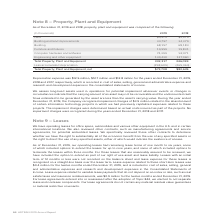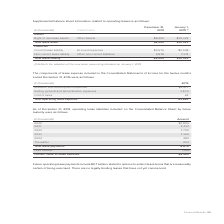According to Adtran's financial document, What types of operating leases does the company have in the U.S. and in certain international locations? office space, automobiles and various other equipment. The document states: "We have operating leases for office space, automobiles and various other equipment in the U.S. and in certain international locations. We also reviewe..." Also, What was the right of use lease assets in December 2019? According to the financial document, $8,452 (in thousands). The relevant text states: "Right of use lease assets Other Assets $8,452 $10,322..." Also, What was the current lease liability in December 2019? According to the financial document, $2,676 (in thousands). The relevant text states: "Current lease liability Accrued expenses $2,676 $2,948..." Also, can you calculate: What was the change in current lease liability between January and December? Based on the calculation: $2,676-$2,948, the result is -272 (in thousands). This is based on the information: "Current lease liability Accrued expenses $2,676 $2,948 Current lease liability Accrued expenses $2,676 $2,948..." The key data points involved are: 2,676, 2,948. Also, can you calculate: What was the change in total lease asset between January and December? Based on the calculation: $8,452-$10,322, the result is -1870 (in thousands). This is based on the information: "Right of use lease assets Other Assets $8,452 $10,322 Right of use lease assets Other Assets $8,452 $10,322..." The key data points involved are: 10,322, 8,452. Also, can you calculate: What was the percentage change in total lease liability between January and December? To answer this question, I need to perform calculations using the financial data. The calculation is: ($8,494-$10,322)/$10,322, which equals -17.71 (percentage). This is based on the information: "Total lease liability $8,494 $10,322 Total lease liability $8,494 $10,322..." The key data points involved are: 10,322, 8,494. 